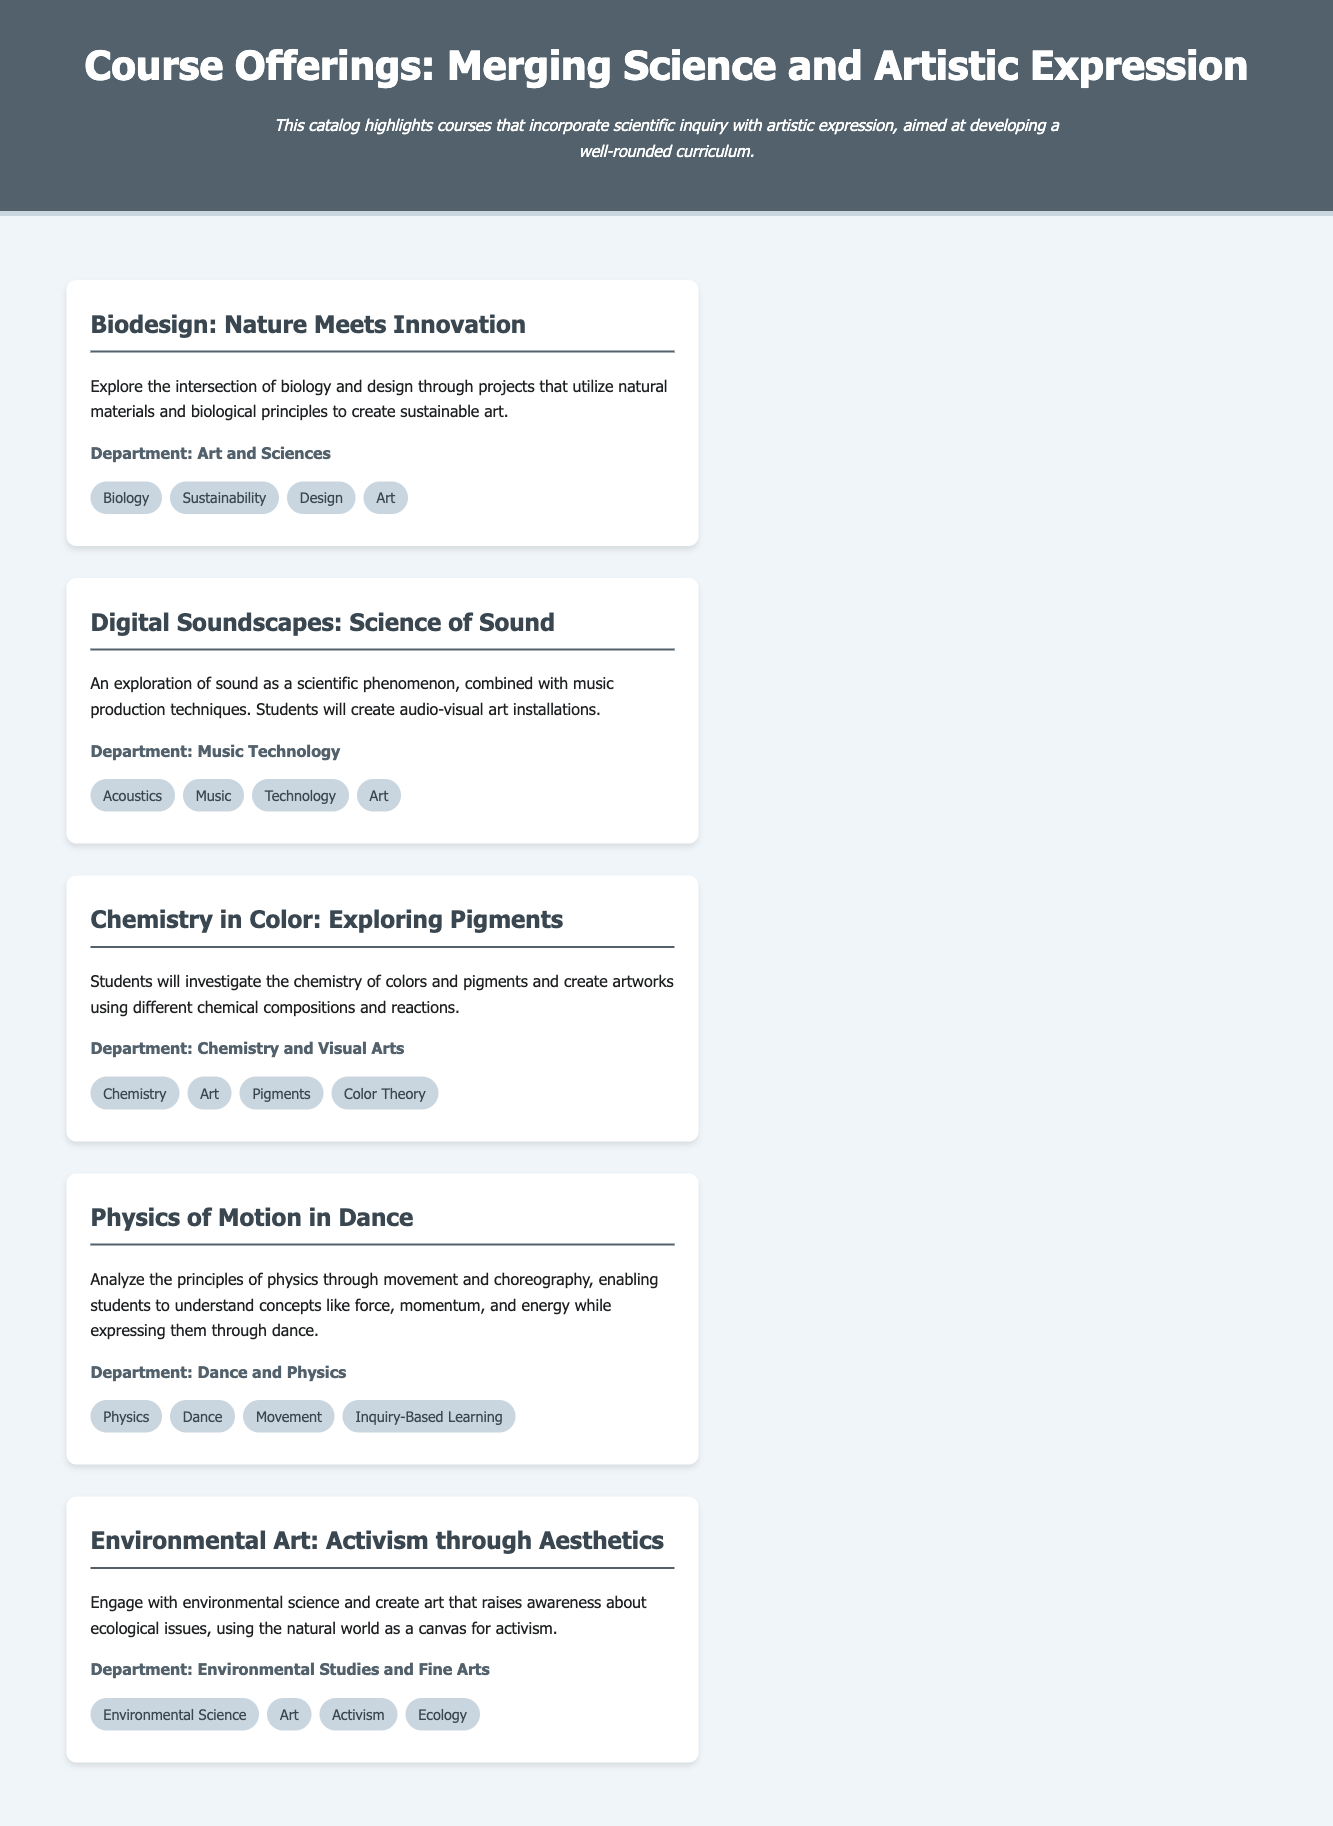What is the title of the catalog? The title of the catalog is presented in the header of the document, which is "Course Offerings: Merging Science and Artistic Expression."
Answer: Course Offerings: Merging Science and Artistic Expression How many courses are listed in the catalog? The document lists five distinct courses that combine scientific inquiry with artistic expression.
Answer: 5 Which department offers the course "Digital Soundscapes: Science of Sound"? Each course in the document includes a department affiliation, with "Digital Soundscapes: Science of Sound" being offered by the "Music Technology" department.
Answer: Music Technology What is a keyword associated with the course "Physics of Motion in Dance"? Keywords are provided for each course, and one associated keyword for "Physics of Motion in Dance" is "Dance."
Answer: Dance Which course involves the investigation of colors and pigments? The course specifically stating an investigation of colors and pigments is titled "Chemistry in Color: Exploring Pigments."
Answer: Chemistry in Color: Exploring Pigments What is the focus of the course "Environmental Art: Activism through Aesthetics"? The course description notes that it focuses on creating art that raises awareness about ecological issues.
Answer: Activism through Aesthetics In which department is the course "Biodesign: Nature Meets Innovation" offered? Each course is associated with a department, and "Biodesign: Nature Meets Innovation" is offered by the "Art and Sciences" department.
Answer: Art and Sciences What artistic element is explored in the course "Digital Soundscapes: Science of Sound"? The artistic element explored in this course is "audio-visual art installations."
Answer: audio-visual art installations 